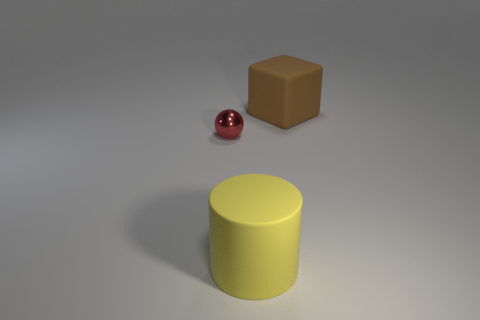Add 1 large purple cubes. How many objects exist? 4 Subtract all balls. How many objects are left? 2 Add 3 tiny red shiny balls. How many tiny red shiny balls are left? 4 Add 2 yellow cylinders. How many yellow cylinders exist? 3 Subtract 0 yellow spheres. How many objects are left? 3 Subtract all red cylinders. Subtract all green blocks. How many cylinders are left? 1 Subtract all cyan spheres. How many blue blocks are left? 0 Subtract all tiny balls. Subtract all large brown matte cubes. How many objects are left? 1 